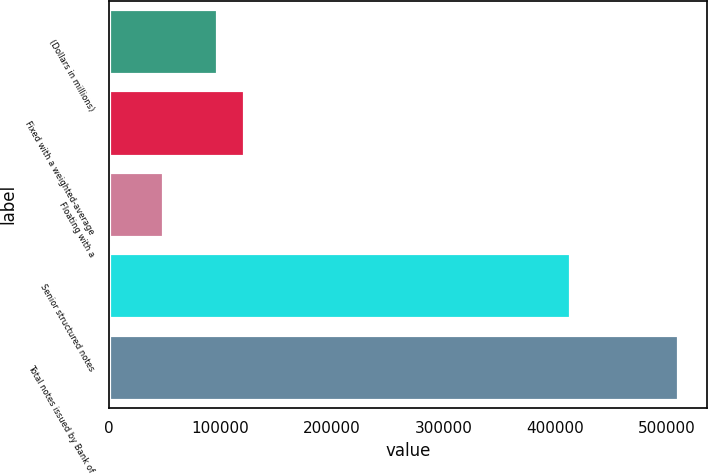Convert chart to OTSL. <chart><loc_0><loc_0><loc_500><loc_500><bar_chart><fcel>(Dollars in millions)<fcel>Fixed with a weighted-average<fcel>Floating with a<fcel>Senior structured notes<fcel>Total notes issued by Bank of<nl><fcel>97256.2<fcel>121570<fcel>48628.6<fcel>413336<fcel>510591<nl></chart> 